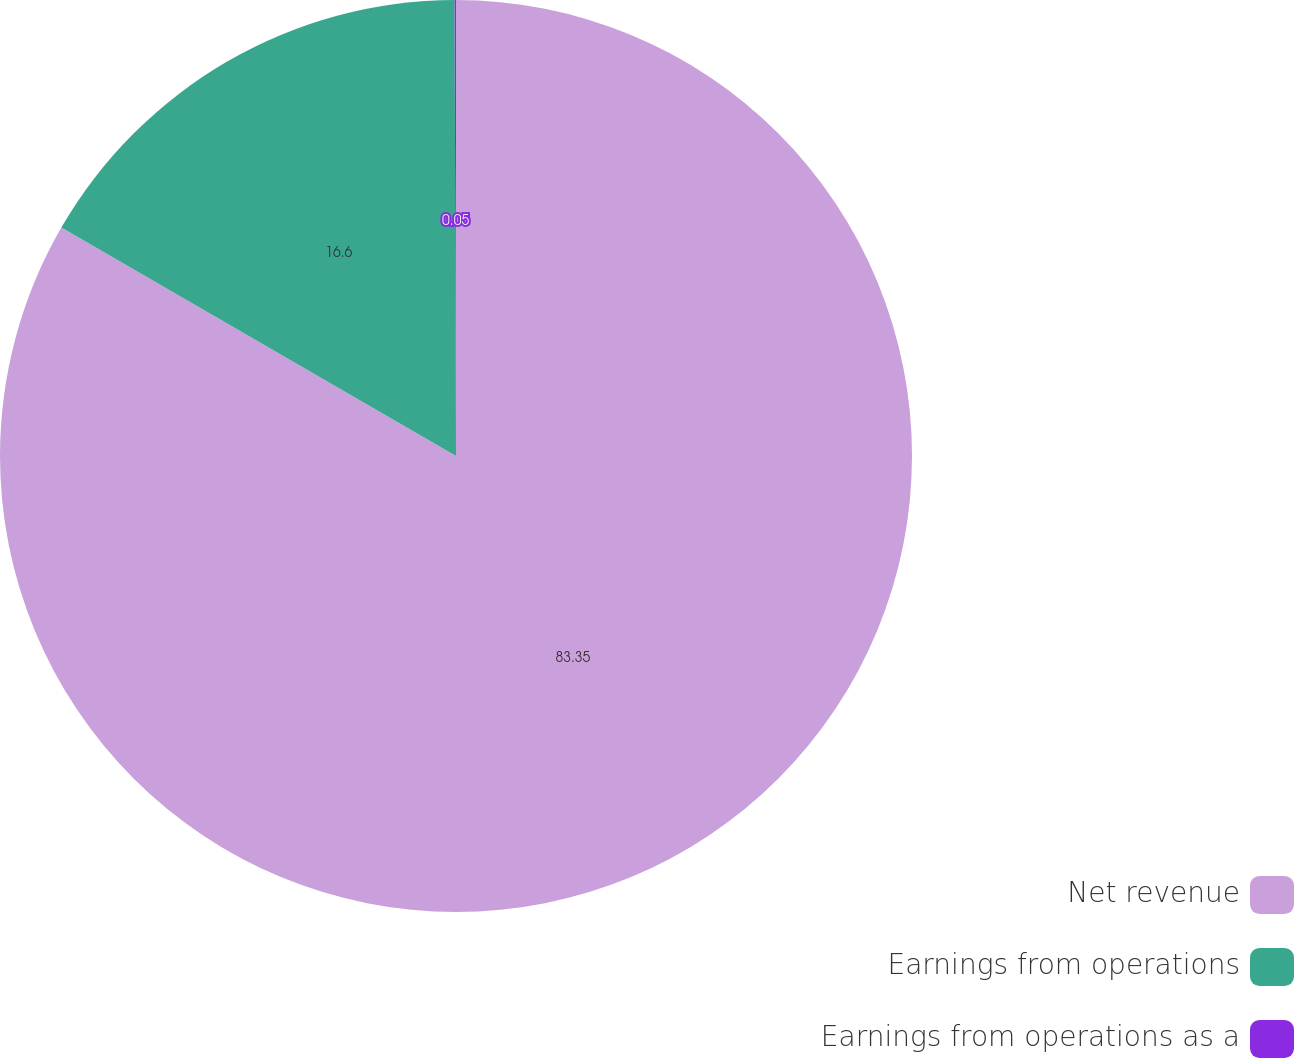Convert chart. <chart><loc_0><loc_0><loc_500><loc_500><pie_chart><fcel>Net revenue<fcel>Earnings from operations<fcel>Earnings from operations as a<nl><fcel>83.35%<fcel>16.6%<fcel>0.05%<nl></chart> 